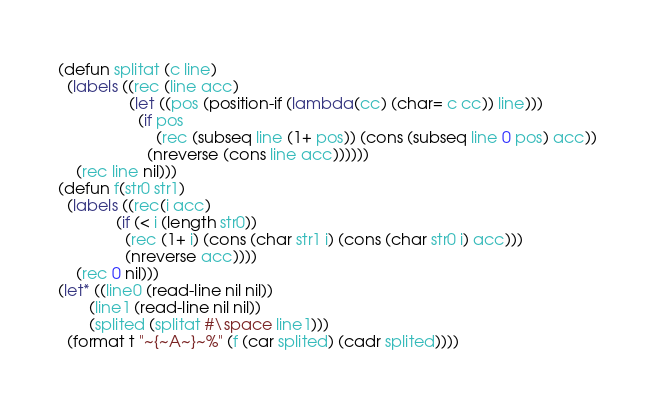Convert code to text. <code><loc_0><loc_0><loc_500><loc_500><_Lisp_>(defun splitat (c line)
  (labels ((rec (line acc)
				(let ((pos (position-if (lambda(cc) (char= c cc)) line)))
				  (if pos
					  (rec (subseq line (1+ pos)) (cons (subseq line 0 pos) acc))
					(nreverse (cons line acc))))))
	(rec line nil)))
(defun f(str0 str1)
  (labels ((rec(i acc)
             (if (< i (length str0))
               (rec (1+ i) (cons (char str1 i) (cons (char str0 i) acc)))
               (nreverse acc))))
    (rec 0 nil)))
(let* ((line0 (read-line nil nil))
       (line1 (read-line nil nil))
       (splited (splitat #\space line1)))
  (format t "~{~A~}~%" (f (car splited) (cadr splited))))
</code> 